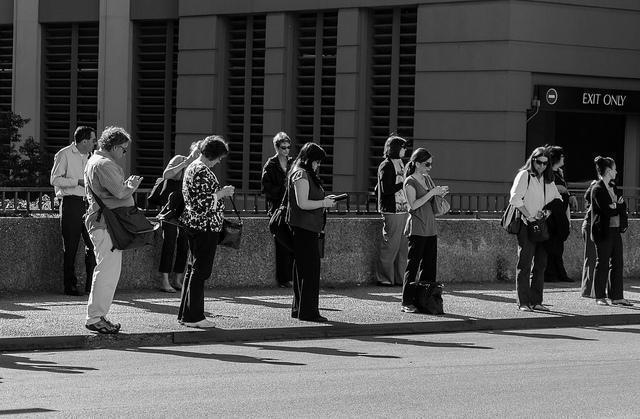What are the people likely doing?
Indicate the correct response by choosing from the four available options to answer the question.
Options: Playing games, reading, waiting, running. Waiting. 